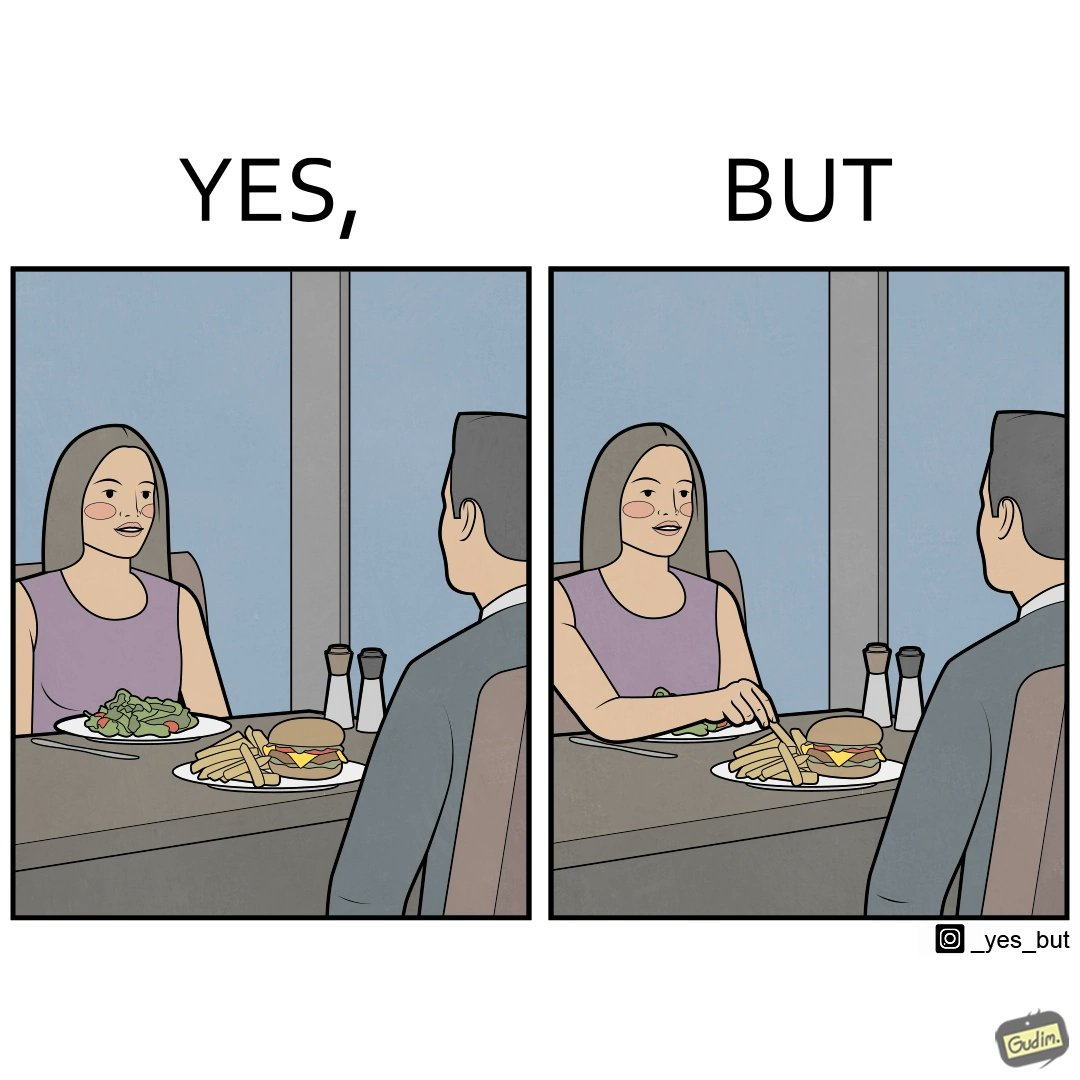What makes this image funny or satirical? The image is ironic because in the first image it is shown that the woman has got salad for her but she is having french fries from the man's plate which displays that the girl is trying to show herself as health conscious by having a plate of salad for her but she wants to have to have fast food but rather than having them for herself she is taking some from other's plate 